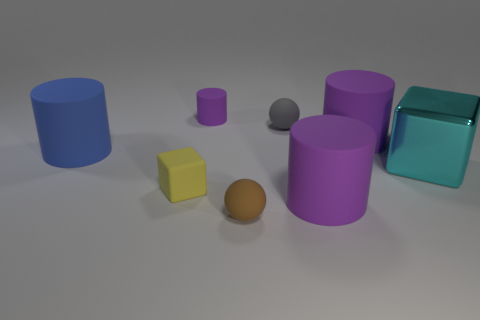Subtract all brown balls. How many purple cylinders are left? 3 Subtract all gray cylinders. Subtract all cyan cubes. How many cylinders are left? 4 Add 2 purple rubber cylinders. How many objects exist? 10 Subtract all balls. How many objects are left? 6 Subtract all brown balls. Subtract all gray matte balls. How many objects are left? 6 Add 3 small matte blocks. How many small matte blocks are left? 4 Add 1 large blue shiny cubes. How many large blue shiny cubes exist? 1 Subtract 0 yellow cylinders. How many objects are left? 8 